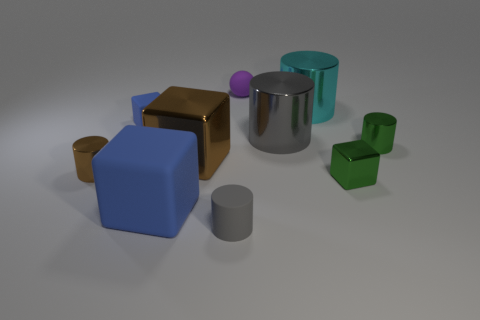The gray matte cylinder is what size?
Your answer should be compact. Small. What number of rubber objects are either big cyan things or blue blocks?
Provide a succinct answer. 2. Are there fewer big cyan metal objects than brown shiny things?
Ensure brevity in your answer.  Yes. How many other objects are there of the same material as the cyan object?
Provide a succinct answer. 5. The gray metal thing that is the same shape as the small brown thing is what size?
Your answer should be very brief. Large. Is the material of the gray thing behind the small brown cylinder the same as the large block that is behind the big matte thing?
Keep it short and to the point. Yes. Is the number of big blocks on the right side of the green block less than the number of small rubber cylinders?
Provide a short and direct response. Yes. Are there any other things that are the same shape as the cyan object?
Make the answer very short. Yes. The other large metallic object that is the same shape as the big cyan thing is what color?
Provide a short and direct response. Gray. Do the shiny cube that is on the left side of the rubber sphere and the big blue block have the same size?
Your answer should be very brief. Yes. 